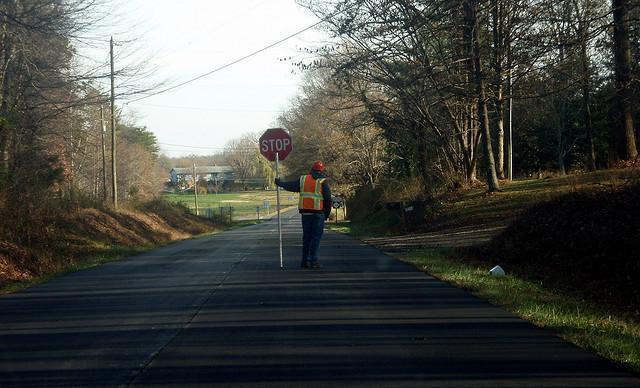How many cars aare parked next to the pile of garbage bags?
Give a very brief answer. 0. 